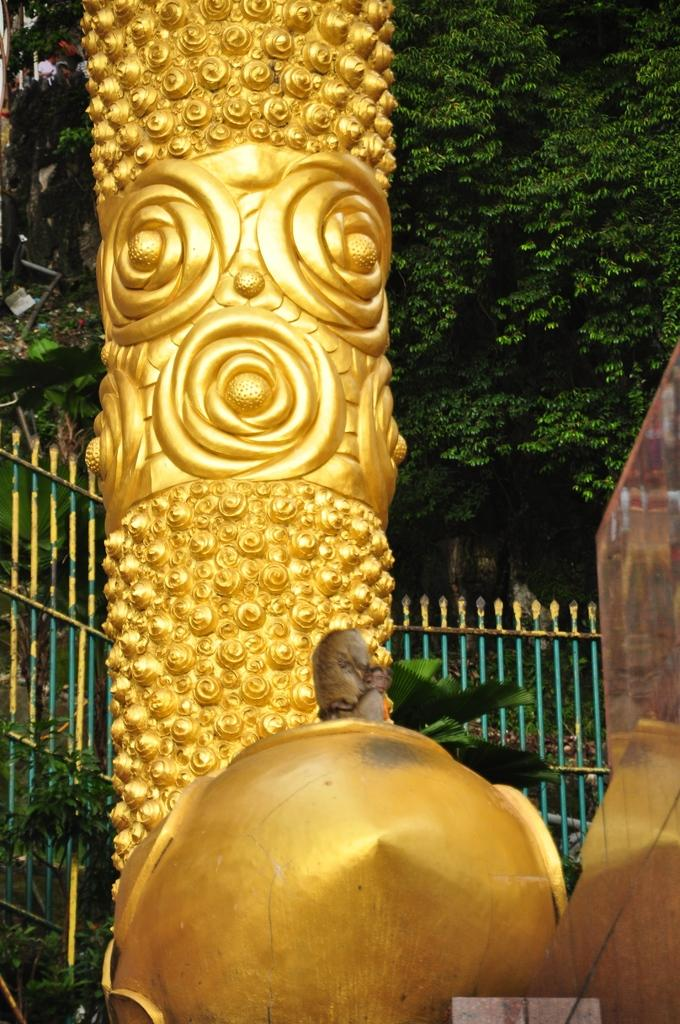What is the main subject in the image? There is a structure in the image. What is the color of the structure? The structure is gold in color. What type of vegetation can be seen on the right side of the image? There are trees on the right side of the image. How many cars are parked near the gold structure in the image? There is no mention of cars in the image, so it is not possible to determine how many cars might be parked near the structure. 